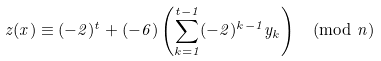<formula> <loc_0><loc_0><loc_500><loc_500>z ( x ) \equiv ( - 2 ) ^ { t } + ( - 6 ) \left ( \sum _ { k = 1 } ^ { t - 1 } ( - 2 ) ^ { k - 1 } y _ { k } \right ) \pmod { n }</formula> 